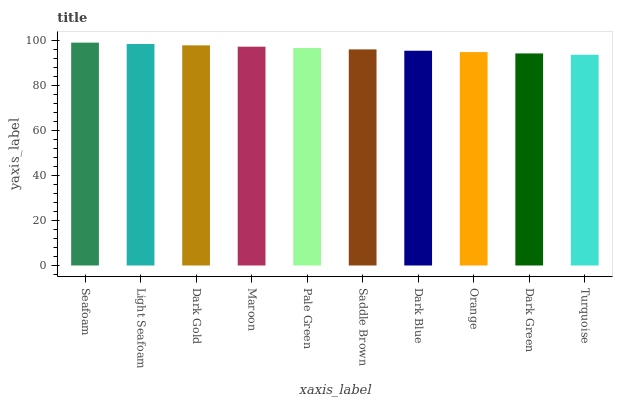Is Turquoise the minimum?
Answer yes or no. Yes. Is Seafoam the maximum?
Answer yes or no. Yes. Is Light Seafoam the minimum?
Answer yes or no. No. Is Light Seafoam the maximum?
Answer yes or no. No. Is Seafoam greater than Light Seafoam?
Answer yes or no. Yes. Is Light Seafoam less than Seafoam?
Answer yes or no. Yes. Is Light Seafoam greater than Seafoam?
Answer yes or no. No. Is Seafoam less than Light Seafoam?
Answer yes or no. No. Is Pale Green the high median?
Answer yes or no. Yes. Is Saddle Brown the low median?
Answer yes or no. Yes. Is Dark Green the high median?
Answer yes or no. No. Is Dark Blue the low median?
Answer yes or no. No. 